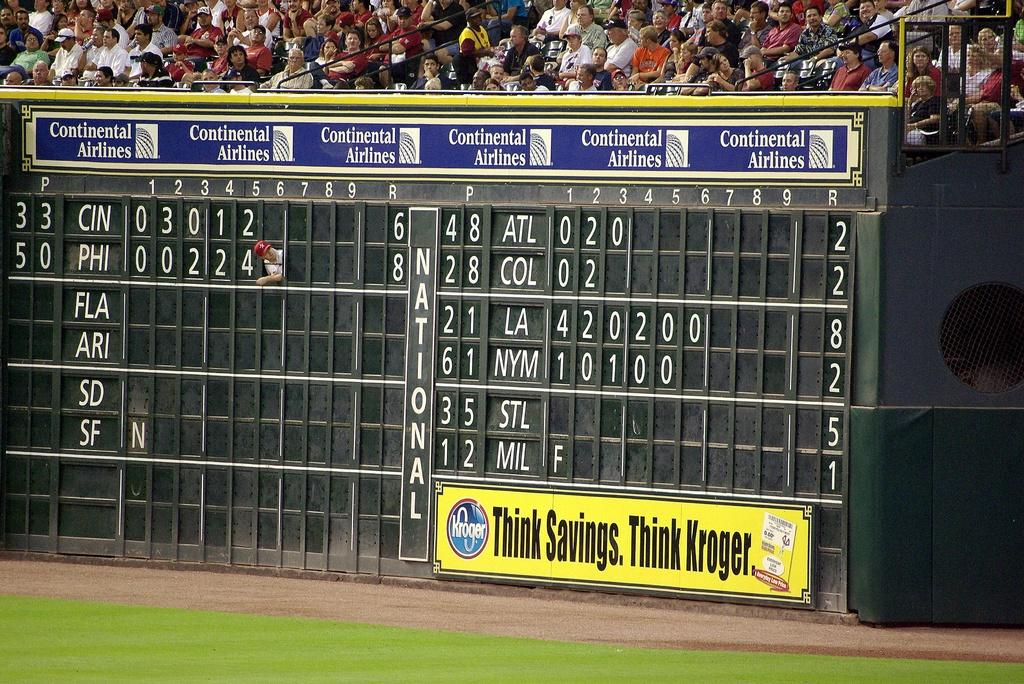Provide a one-sentence caption for the provided image. A large black baseball scoreboard with Continental Airlines on it. 